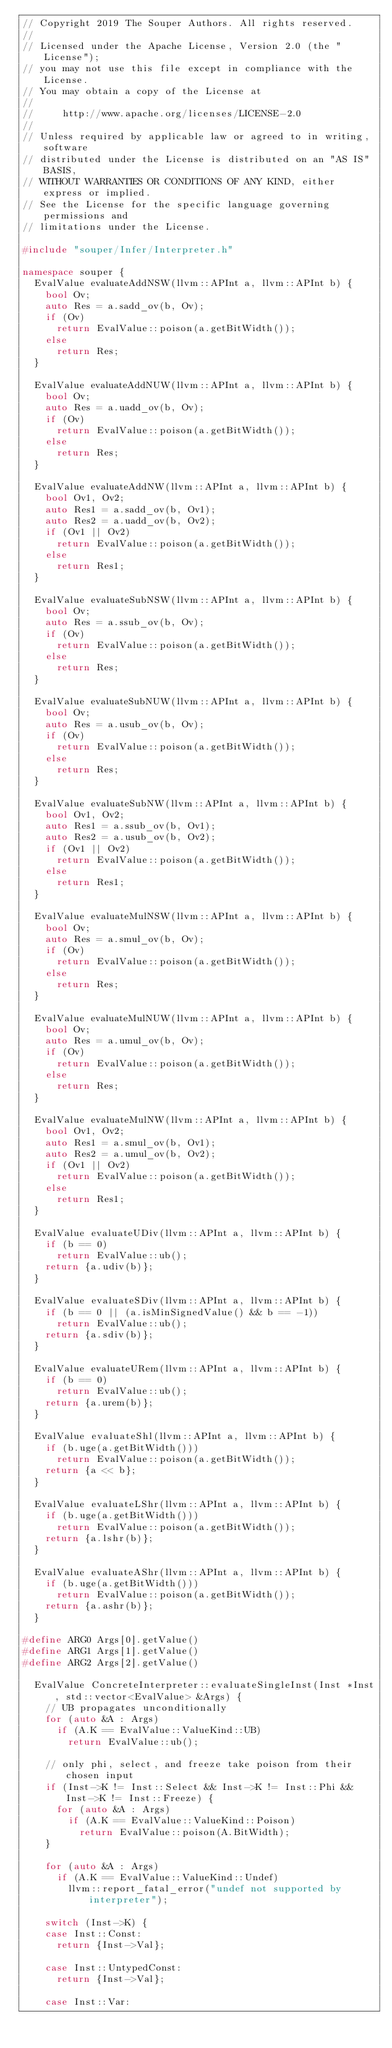<code> <loc_0><loc_0><loc_500><loc_500><_C++_>// Copyright 2019 The Souper Authors. All rights reserved.
//
// Licensed under the Apache License, Version 2.0 (the "License");
// you may not use this file except in compliance with the License.
// You may obtain a copy of the License at
//
//     http://www.apache.org/licenses/LICENSE-2.0
//
// Unless required by applicable law or agreed to in writing, software
// distributed under the License is distributed on an "AS IS" BASIS,
// WITHOUT WARRANTIES OR CONDITIONS OF ANY KIND, either express or implied.
// See the License for the specific language governing permissions and
// limitations under the License.

#include "souper/Infer/Interpreter.h"

namespace souper {
  EvalValue evaluateAddNSW(llvm::APInt a, llvm::APInt b) {
    bool Ov;
    auto Res = a.sadd_ov(b, Ov);
    if (Ov)
      return EvalValue::poison(a.getBitWidth());
    else
      return Res;
  }

  EvalValue evaluateAddNUW(llvm::APInt a, llvm::APInt b) {
    bool Ov;
    auto Res = a.uadd_ov(b, Ov);
    if (Ov)
      return EvalValue::poison(a.getBitWidth());
    else
      return Res;
  }

  EvalValue evaluateAddNW(llvm::APInt a, llvm::APInt b) {
    bool Ov1, Ov2;
    auto Res1 = a.sadd_ov(b, Ov1);
    auto Res2 = a.uadd_ov(b, Ov2);
    if (Ov1 || Ov2)
      return EvalValue::poison(a.getBitWidth());
    else
      return Res1;
  }

  EvalValue evaluateSubNSW(llvm::APInt a, llvm::APInt b) {
    bool Ov;
    auto Res = a.ssub_ov(b, Ov);
    if (Ov)
      return EvalValue::poison(a.getBitWidth());
    else
      return Res;
  }

  EvalValue evaluateSubNUW(llvm::APInt a, llvm::APInt b) {
    bool Ov;
    auto Res = a.usub_ov(b, Ov);
    if (Ov)
      return EvalValue::poison(a.getBitWidth());
    else
      return Res;
  }

  EvalValue evaluateSubNW(llvm::APInt a, llvm::APInt b) {
    bool Ov1, Ov2;
    auto Res1 = a.ssub_ov(b, Ov1);
    auto Res2 = a.usub_ov(b, Ov2);
    if (Ov1 || Ov2)
      return EvalValue::poison(a.getBitWidth());
    else
      return Res1;
  }

  EvalValue evaluateMulNSW(llvm::APInt a, llvm::APInt b) {
    bool Ov;
    auto Res = a.smul_ov(b, Ov);
    if (Ov)
      return EvalValue::poison(a.getBitWidth());
    else
      return Res;
  }

  EvalValue evaluateMulNUW(llvm::APInt a, llvm::APInt b) {
    bool Ov;
    auto Res = a.umul_ov(b, Ov);
    if (Ov)
      return EvalValue::poison(a.getBitWidth());
    else
      return Res;
  }

  EvalValue evaluateMulNW(llvm::APInt a, llvm::APInt b) {
    bool Ov1, Ov2;
    auto Res1 = a.smul_ov(b, Ov1);
    auto Res2 = a.umul_ov(b, Ov2);
    if (Ov1 || Ov2)
      return EvalValue::poison(a.getBitWidth());
    else
      return Res1;
  }

  EvalValue evaluateUDiv(llvm::APInt a, llvm::APInt b) {
    if (b == 0)
      return EvalValue::ub();
    return {a.udiv(b)};
  }

  EvalValue evaluateSDiv(llvm::APInt a, llvm::APInt b) {
    if (b == 0 || (a.isMinSignedValue() && b == -1))
      return EvalValue::ub();
    return {a.sdiv(b)};
  }

  EvalValue evaluateURem(llvm::APInt a, llvm::APInt b) {
    if (b == 0)
      return EvalValue::ub();
    return {a.urem(b)};
  }

  EvalValue evaluateShl(llvm::APInt a, llvm::APInt b) {
    if (b.uge(a.getBitWidth()))
      return EvalValue::poison(a.getBitWidth());
    return {a << b};
  }

  EvalValue evaluateLShr(llvm::APInt a, llvm::APInt b) {
    if (b.uge(a.getBitWidth()))
      return EvalValue::poison(a.getBitWidth());
    return {a.lshr(b)};
  }

  EvalValue evaluateAShr(llvm::APInt a, llvm::APInt b) {
    if (b.uge(a.getBitWidth()))
      return EvalValue::poison(a.getBitWidth());
    return {a.ashr(b)};
  }

#define ARG0 Args[0].getValue()
#define ARG1 Args[1].getValue()
#define ARG2 Args[2].getValue()

  EvalValue ConcreteInterpreter::evaluateSingleInst(Inst *Inst, std::vector<EvalValue> &Args) {
    // UB propagates unconditionally
    for (auto &A : Args)
      if (A.K == EvalValue::ValueKind::UB)
        return EvalValue::ub();

    // only phi, select, and freeze take poison from their chosen input
    if (Inst->K != Inst::Select && Inst->K != Inst::Phi && Inst->K != Inst::Freeze) {
      for (auto &A : Args)
        if (A.K == EvalValue::ValueKind::Poison)
          return EvalValue::poison(A.BitWidth);
    }

    for (auto &A : Args)
      if (A.K == EvalValue::ValueKind::Undef)
        llvm::report_fatal_error("undef not supported by interpreter");

    switch (Inst->K) {
    case Inst::Const:
      return {Inst->Val};

    case Inst::UntypedConst:
      return {Inst->Val};

    case Inst::Var:</code> 